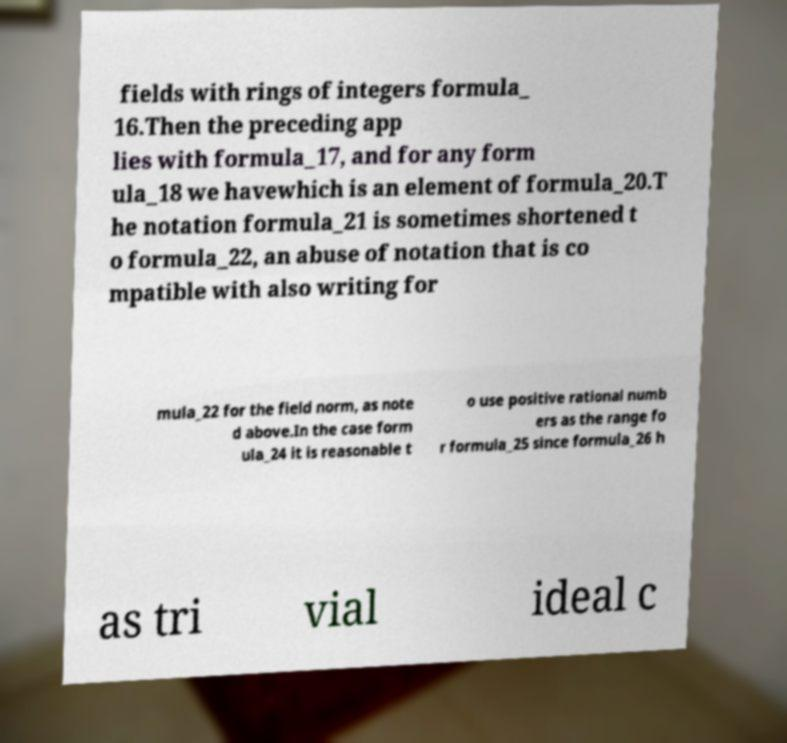Could you assist in decoding the text presented in this image and type it out clearly? fields with rings of integers formula_ 16.Then the preceding app lies with formula_17, and for any form ula_18 we havewhich is an element of formula_20.T he notation formula_21 is sometimes shortened t o formula_22, an abuse of notation that is co mpatible with also writing for mula_22 for the field norm, as note d above.In the case form ula_24 it is reasonable t o use positive rational numb ers as the range fo r formula_25 since formula_26 h as tri vial ideal c 